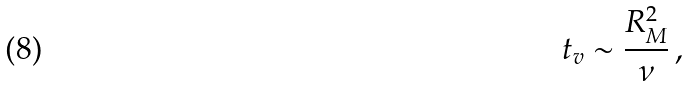<formula> <loc_0><loc_0><loc_500><loc_500>t _ { v } \sim \frac { R _ { M } ^ { 2 } } { \nu } \, ,</formula> 